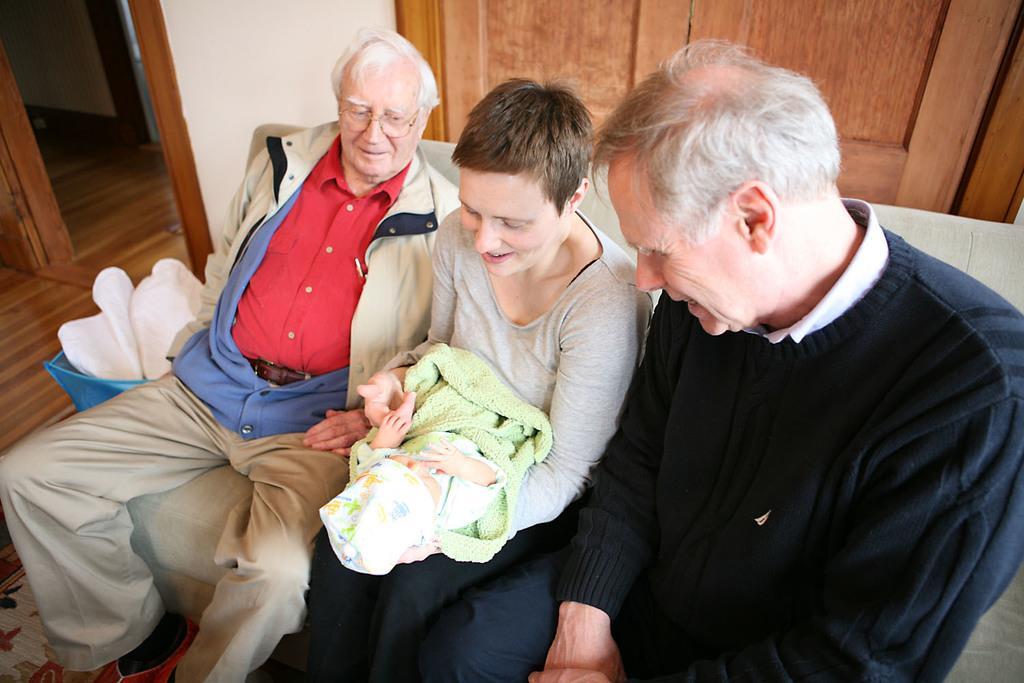In one or two sentences, can you explain what this image depicts? In this image I can see in the middle a woman is sitting on the sofa by holding the baby. Beside her two old men are sitting, at the top it looks like a door. 